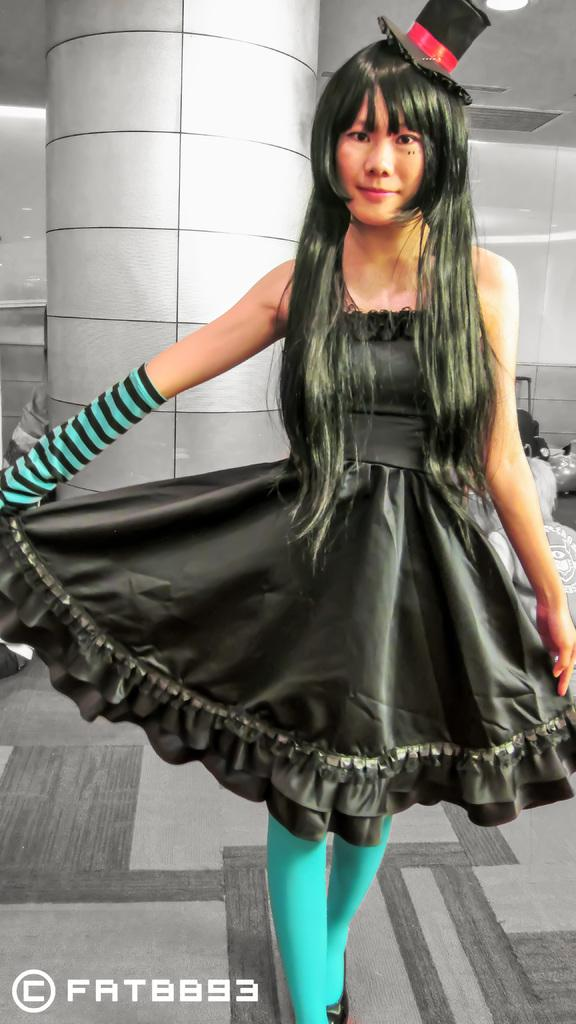Who is the main subject in the image? There is a lady in the image. What is the lady wearing on her head? The lady is wearing a hat. What is the lady's posture in the image? The lady is standing. What can be seen in the background of the image? There is a pole in the background of the image. Can you describe any additional features of the image? There is a watermark in the left bottom corner of the image. What type of snail can be seen crawling on the lady's hat in the image? There is no snail present on the lady's hat in the image. What color is the paint used to decorate the pole in the background? There is no paint visible on the pole in the background of the image. 